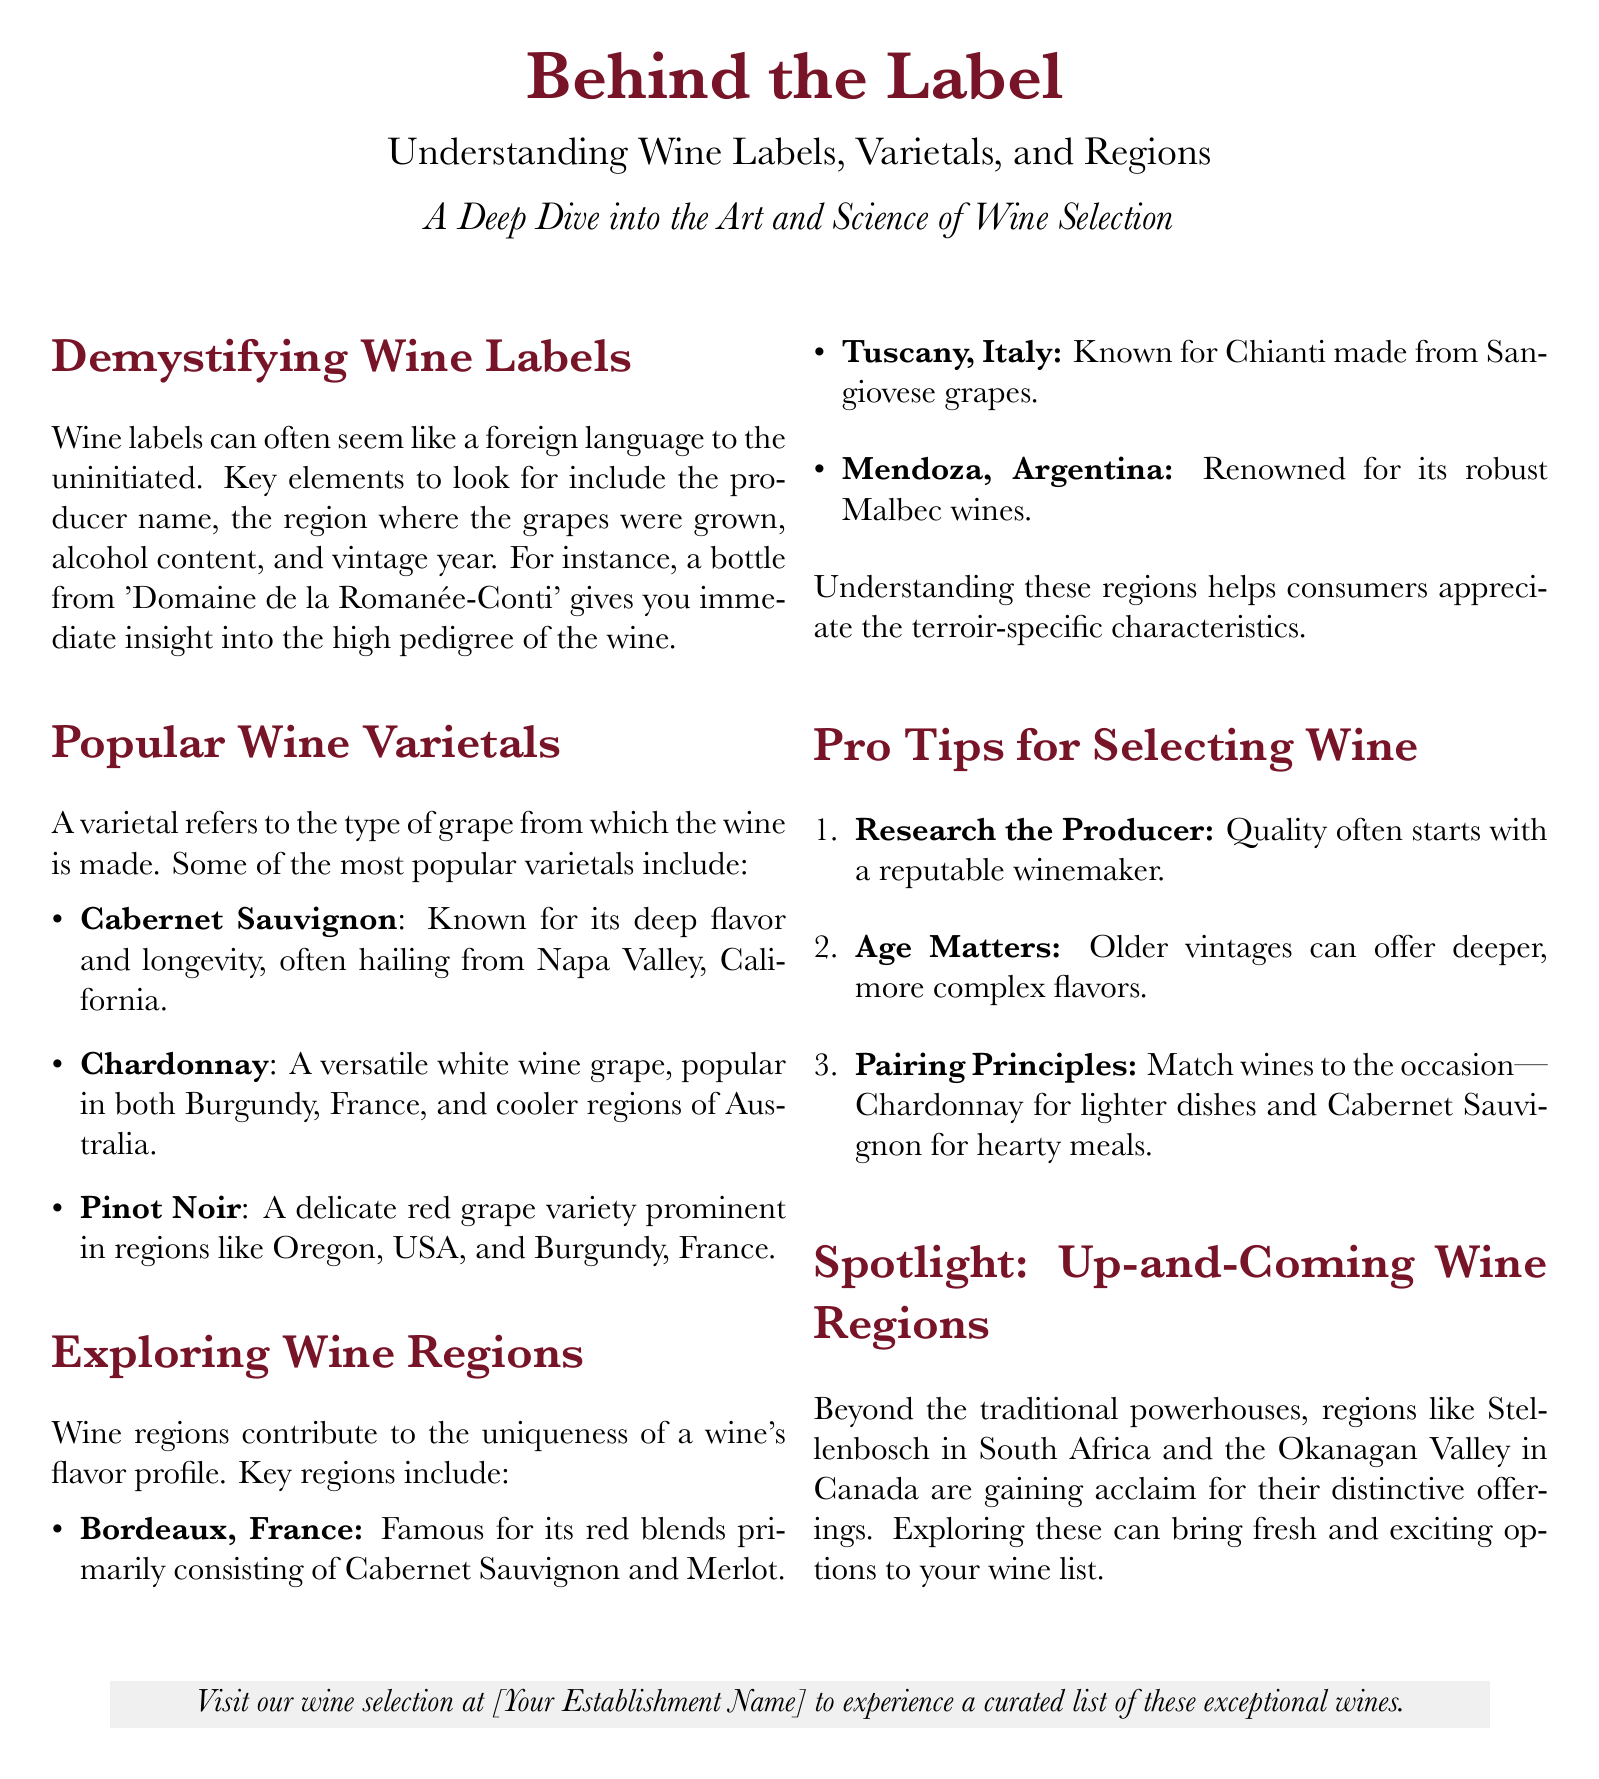What are the key elements to look for on a wine label? The document lists producer name, region, alcohol content, and vintage year as key elements on a wine label.
Answer: producer name, region, alcohol content, vintage year Name a popular wine varietal known for its longevity. According to the document, Cabernet Sauvignon is known for its deep flavor and longevity.
Answer: Cabernet Sauvignon Which wine region is famous for red blends? The document states that Bordeaux, France is famous for its red blends.
Answer: Bordeaux, France What is the recommended pairing for Chardonnay? The document mentions matching Chardonnay with lighter dishes.
Answer: lighter dishes Identify an up-and-coming wine region mentioned in the document. The document highlights Stellenbosch in South Africa as an up-and-coming wine region.
Answer: Stellenbosch How many tips for selecting wine are provided? The document lists three tips for selecting wine.
Answer: three What does the term "varietal" refer to? The document explains that a varietal refers to the type of grape from which the wine is made.
Answer: type of grape Which varietal is popular in both Burgundy, France, and Australia? Chardonnay is mentioned as popular in both Burgundy, France, and cooler regions of Australia.
Answer: Chardonnay What is the significance of terroir in wine? The document indicates that understanding regions helps appreciate terroir-specific characteristics.
Answer: terroir-specific characteristics 